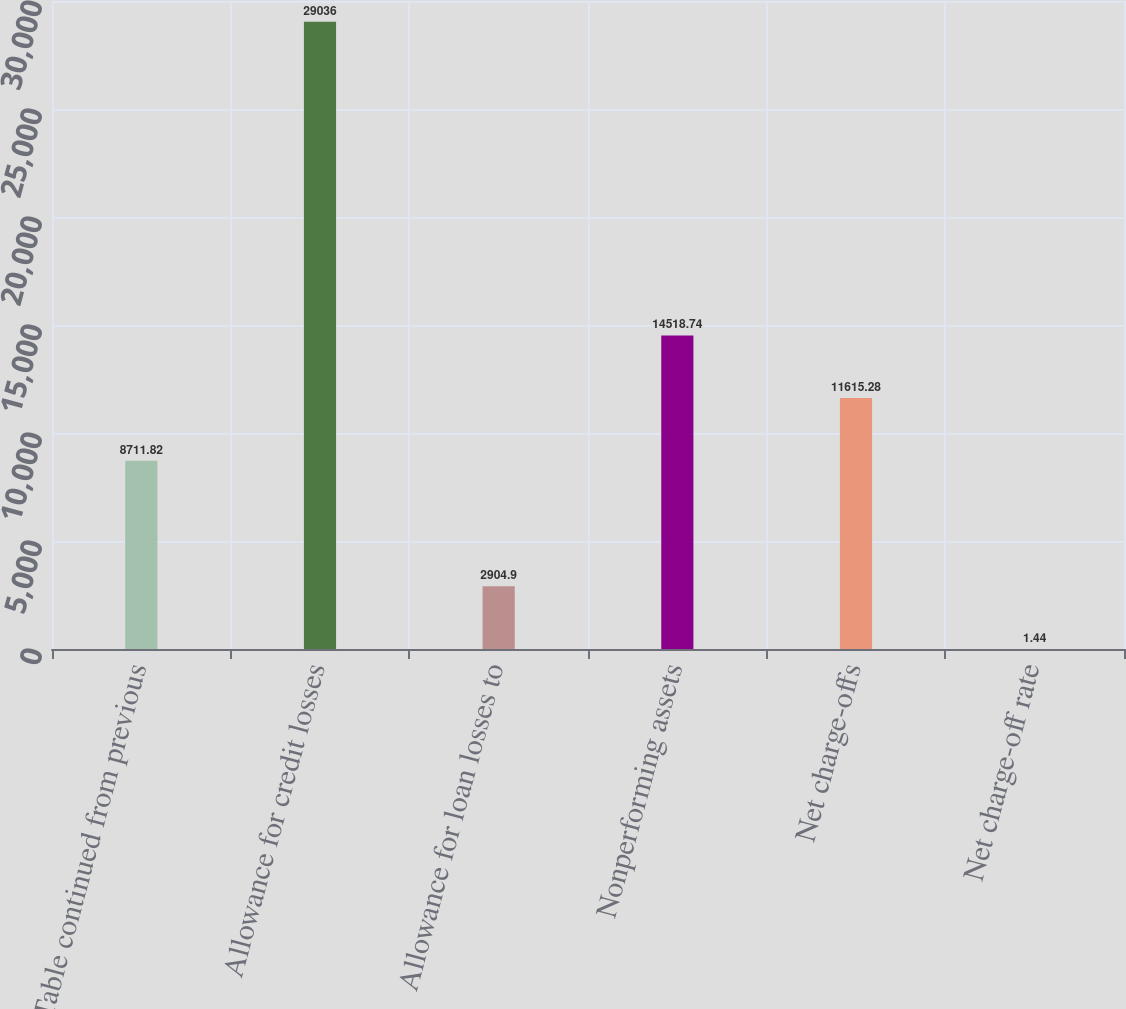Convert chart. <chart><loc_0><loc_0><loc_500><loc_500><bar_chart><fcel>(Table continued from previous<fcel>Allowance for credit losses<fcel>Allowance for loan losses to<fcel>Nonperforming assets<fcel>Net charge-offs<fcel>Net charge-off rate<nl><fcel>8711.82<fcel>29036<fcel>2904.9<fcel>14518.7<fcel>11615.3<fcel>1.44<nl></chart> 